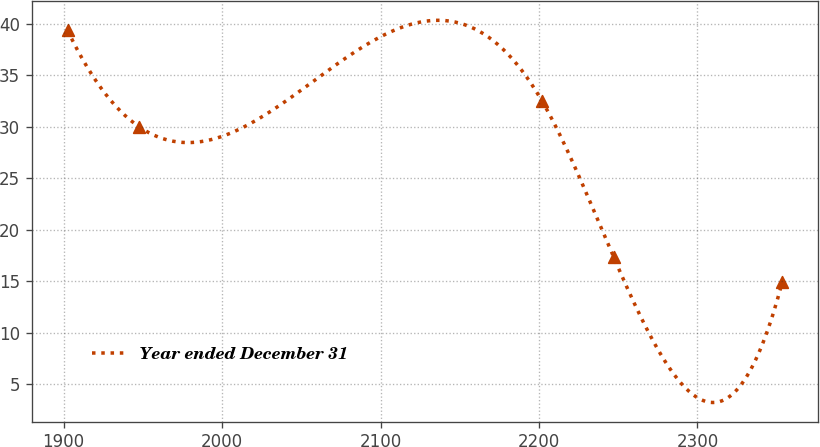Convert chart. <chart><loc_0><loc_0><loc_500><loc_500><line_chart><ecel><fcel>Year ended December 31<nl><fcel>1902.43<fcel>39.38<nl><fcel>1947.53<fcel>30.02<nl><fcel>2202.07<fcel>32.47<nl><fcel>2247.17<fcel>17.34<nl><fcel>2353.46<fcel>14.89<nl></chart> 